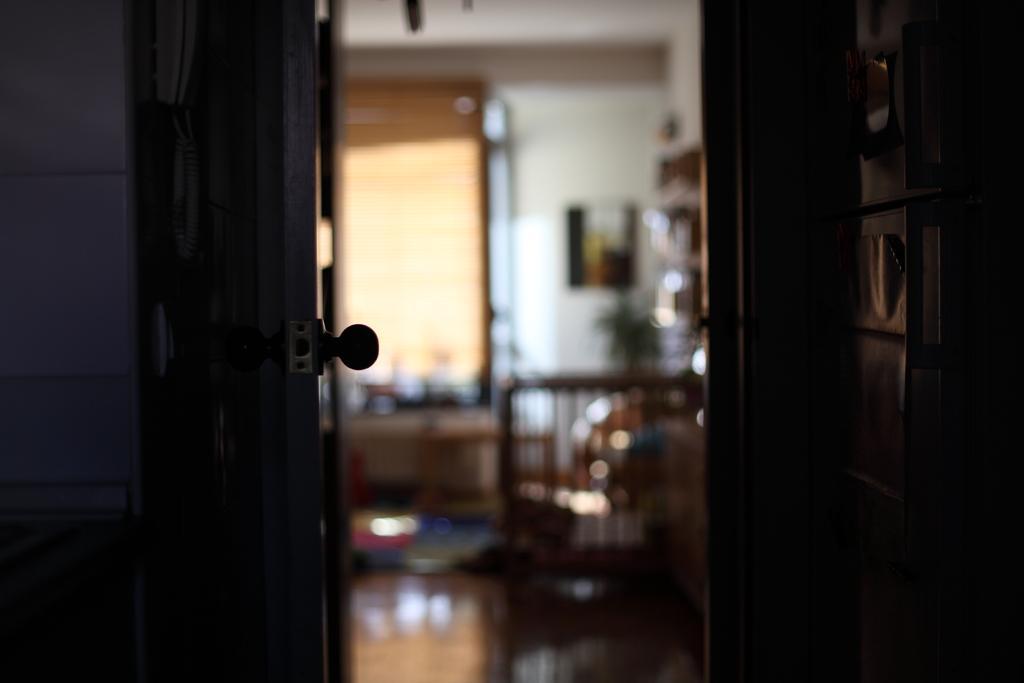Please provide a concise description of this image. In this image in the front there is a door, on the right side there is a cupboard and the background seems to be blurred and there are objects in the background. In the front on the left side there are objects which are visible. 